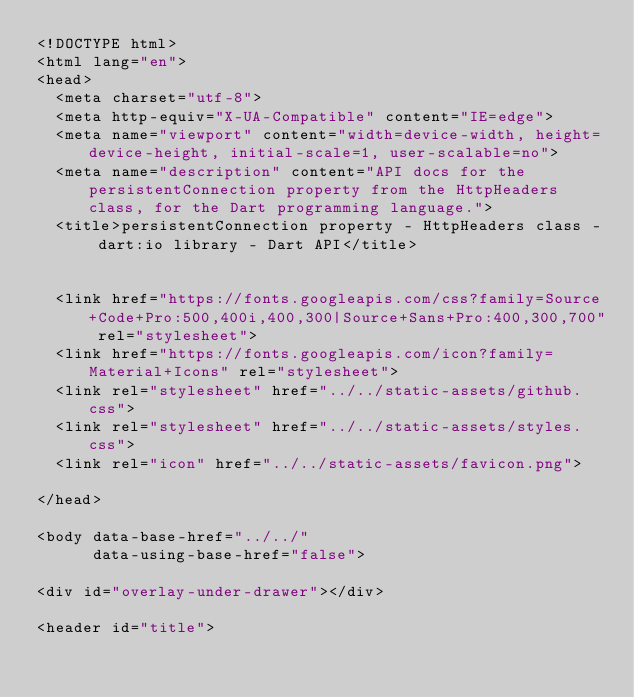Convert code to text. <code><loc_0><loc_0><loc_500><loc_500><_HTML_><!DOCTYPE html>
<html lang="en">
<head>
  <meta charset="utf-8">
  <meta http-equiv="X-UA-Compatible" content="IE=edge">
  <meta name="viewport" content="width=device-width, height=device-height, initial-scale=1, user-scalable=no">
  <meta name="description" content="API docs for the persistentConnection property from the HttpHeaders class, for the Dart programming language.">
  <title>persistentConnection property - HttpHeaders class - dart:io library - Dart API</title>

  
  <link href="https://fonts.googleapis.com/css?family=Source+Code+Pro:500,400i,400,300|Source+Sans+Pro:400,300,700" rel="stylesheet">
  <link href="https://fonts.googleapis.com/icon?family=Material+Icons" rel="stylesheet">
  <link rel="stylesheet" href="../../static-assets/github.css">
  <link rel="stylesheet" href="../../static-assets/styles.css">
  <link rel="icon" href="../../static-assets/favicon.png">

</head>

<body data-base-href="../../"
      data-using-base-href="false">

<div id="overlay-under-drawer"></div>

<header id="title"></code> 